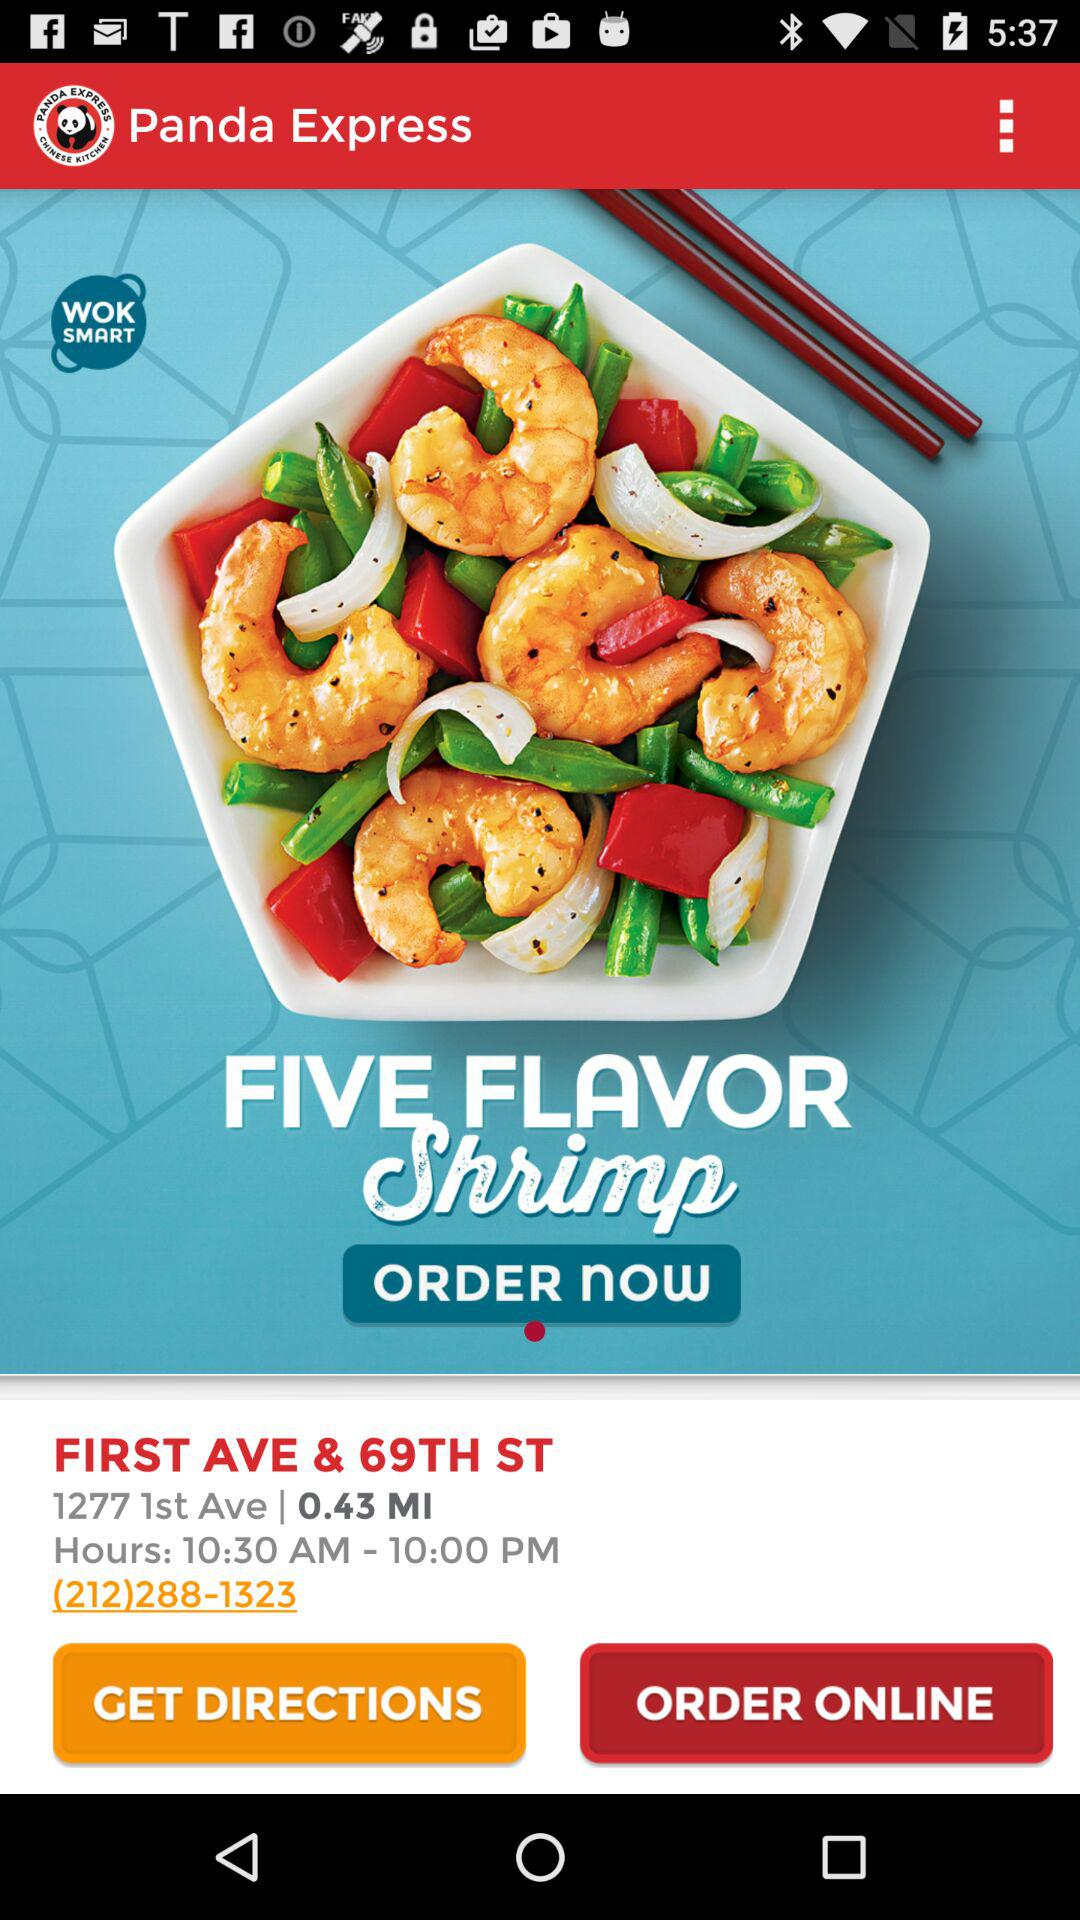What is the address of the restaurant? The address of the restaurant is First Avenue and 69th Street, 1277 1st Avenue. 